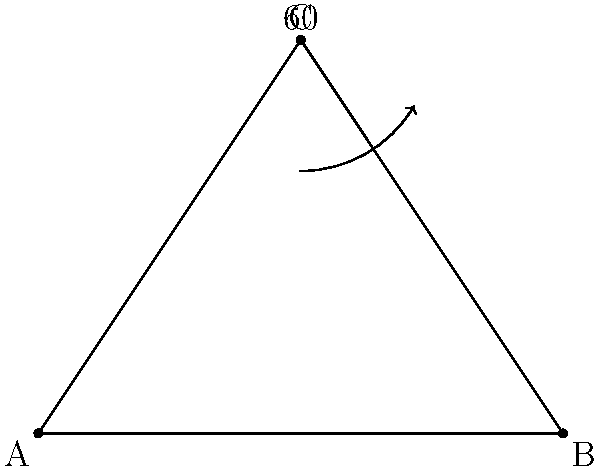Based on your experience with security camera placements, estimate the field of view angle for a camera positioned at point C to cover the entire area of triangle ABC. The angle at vertex C is given as 60°. What is the minimum field of view angle required? Let's approach this step-by-step:

1) In a triangle, the sum of all angles is always 180°.

2) We're given that the angle at C is 60°. Let's call the angles at A and B as x and y respectively.

   $x + y + 60° = 180°$
   $x + y = 120°$

3) For the camera to cover the entire triangle, it needs to see both points A and B from point C.

4) The angle between CA and CB is already 60°.

5) To ensure full coverage, we need to add a small buffer on each side. A common practice in security camera placement is to add about 5° on each side for a safety margin.

6) Therefore, the minimum field of view angle would be:

   $60° + 5° + 5° = 70°$

This 70° field of view would ensure that the camera captures the entire triangle with a small margin on each side for better coverage.
Answer: 70° 